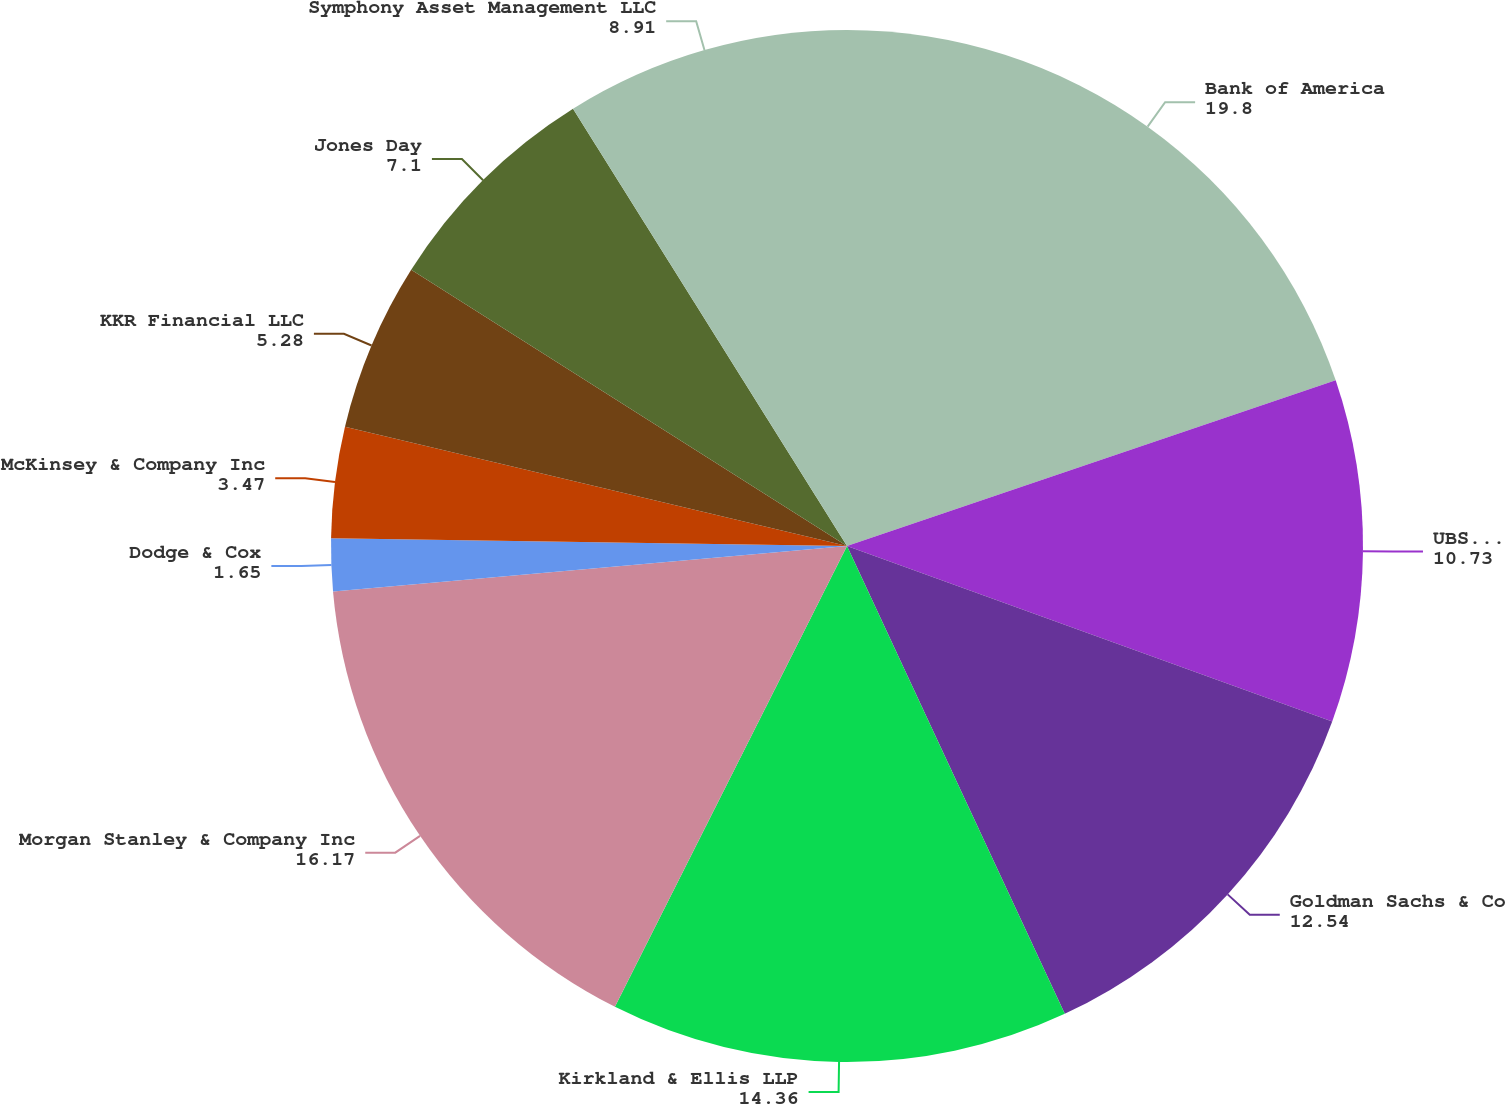Convert chart to OTSL. <chart><loc_0><loc_0><loc_500><loc_500><pie_chart><fcel>Bank of America<fcel>UBS Financial Services<fcel>Goldman Sachs & Co<fcel>Kirkland & Ellis LLP<fcel>Morgan Stanley & Company Inc<fcel>Dodge & Cox<fcel>McKinsey & Company Inc<fcel>KKR Financial LLC<fcel>Jones Day<fcel>Symphony Asset Management LLC<nl><fcel>19.8%<fcel>10.73%<fcel>12.54%<fcel>14.36%<fcel>16.17%<fcel>1.65%<fcel>3.47%<fcel>5.28%<fcel>7.1%<fcel>8.91%<nl></chart> 